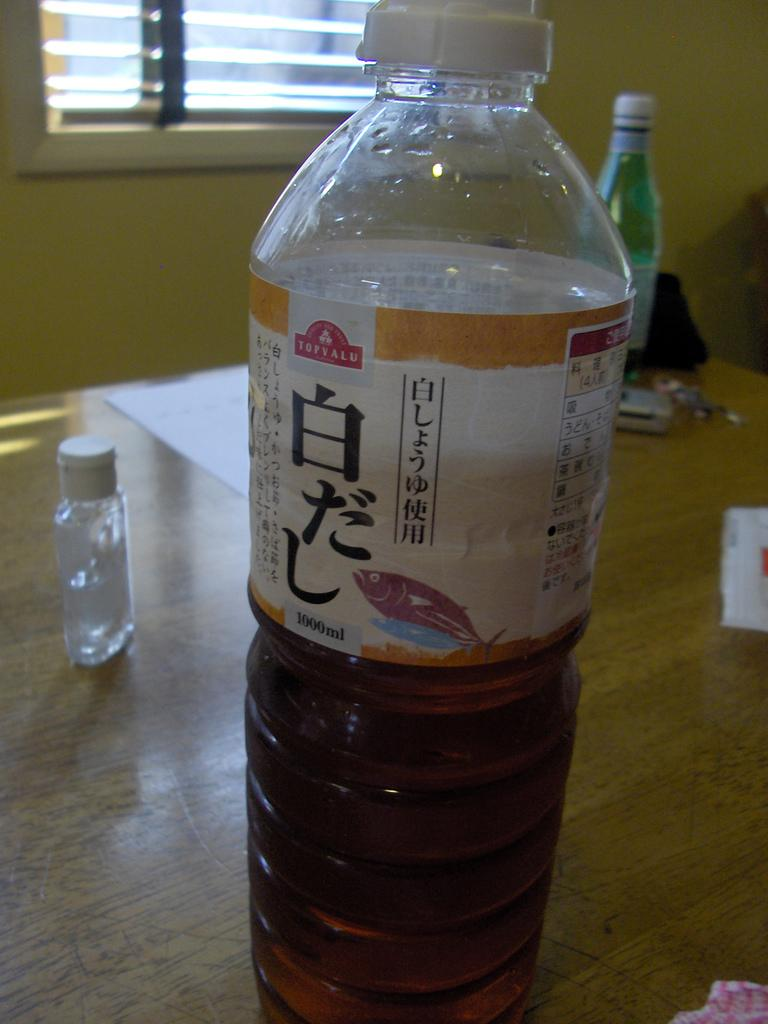<image>
Write a terse but informative summary of the picture. Bottle of TOPVALU with brown liquid inside of it. 